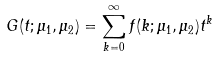<formula> <loc_0><loc_0><loc_500><loc_500>G ( t ; \mu _ { 1 } , \mu _ { 2 } ) = \sum _ { k = 0 } ^ { \infty } f ( k ; \mu _ { 1 } , \mu _ { 2 } ) t ^ { k }</formula> 